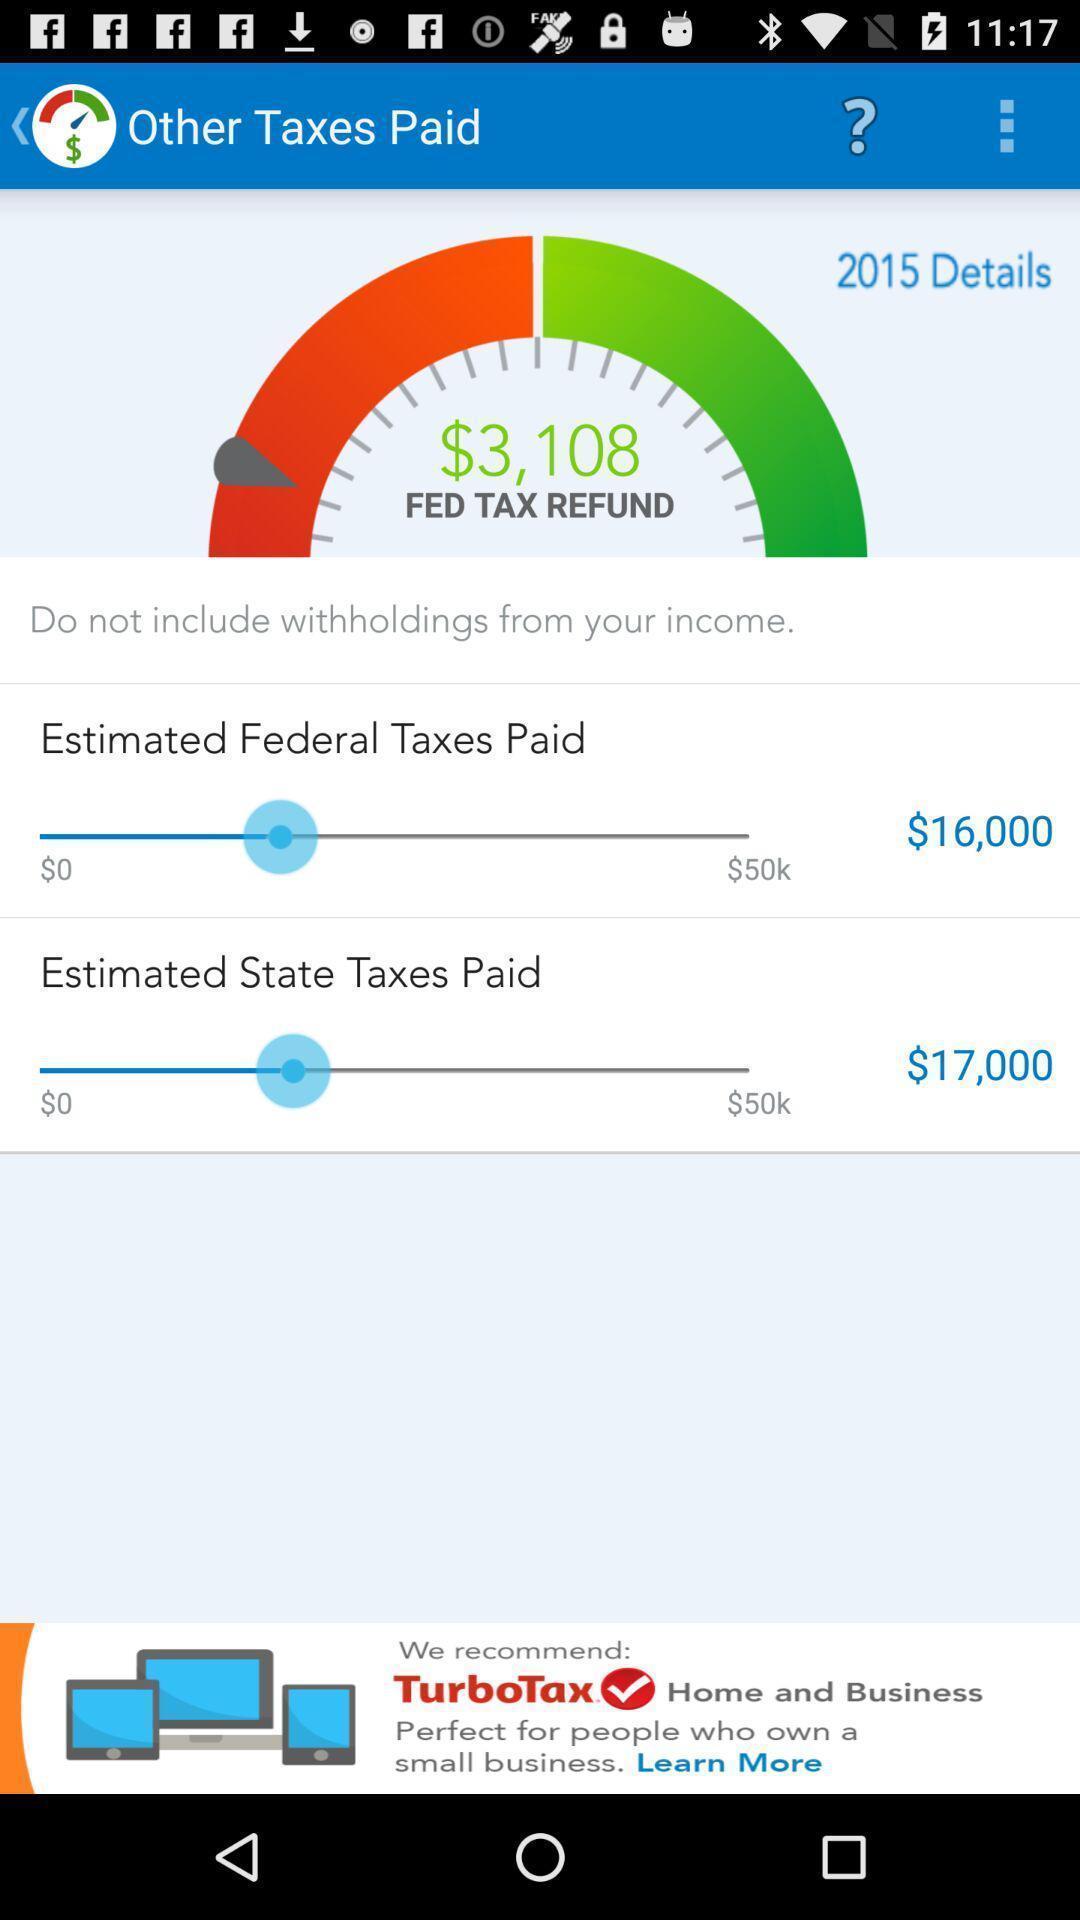Give me a summary of this screen capture. Page displaying the status. 